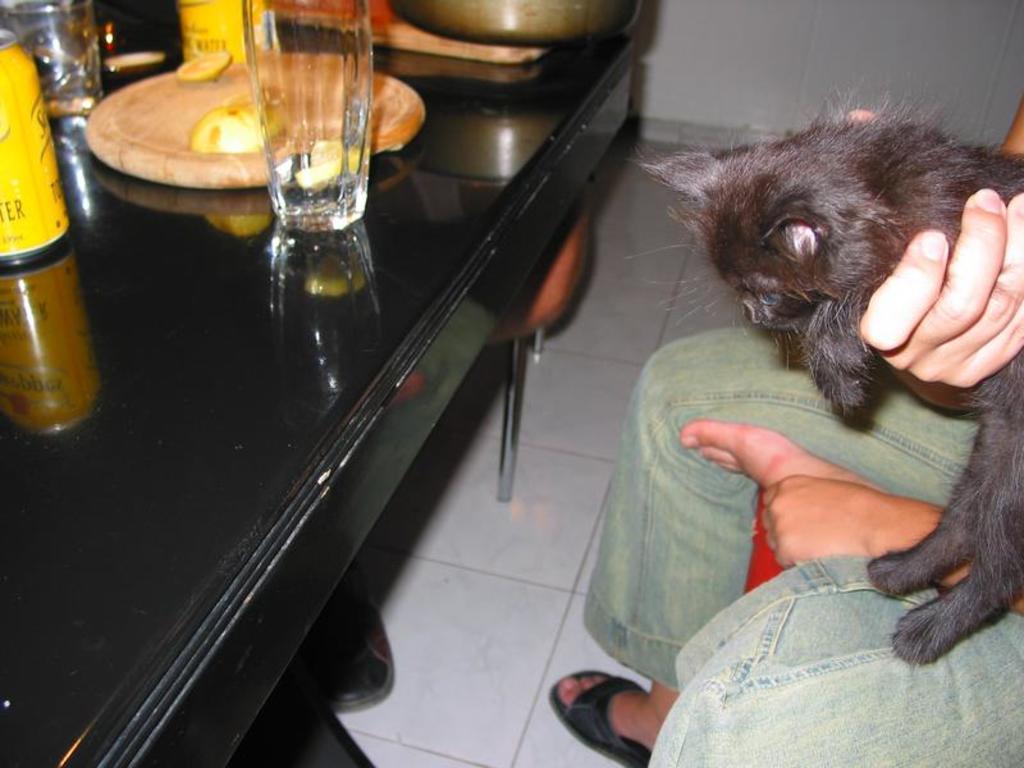Please provide a concise description of this image. In this picture there is a person holding a cat and has a table in front of it. 